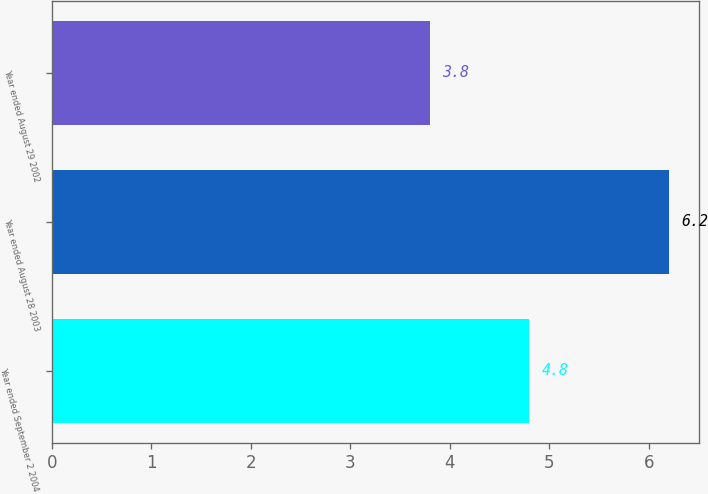Convert chart to OTSL. <chart><loc_0><loc_0><loc_500><loc_500><bar_chart><fcel>Year ended September 2 2004<fcel>Year ended August 28 2003<fcel>Year ended August 29 2002<nl><fcel>4.8<fcel>6.2<fcel>3.8<nl></chart> 